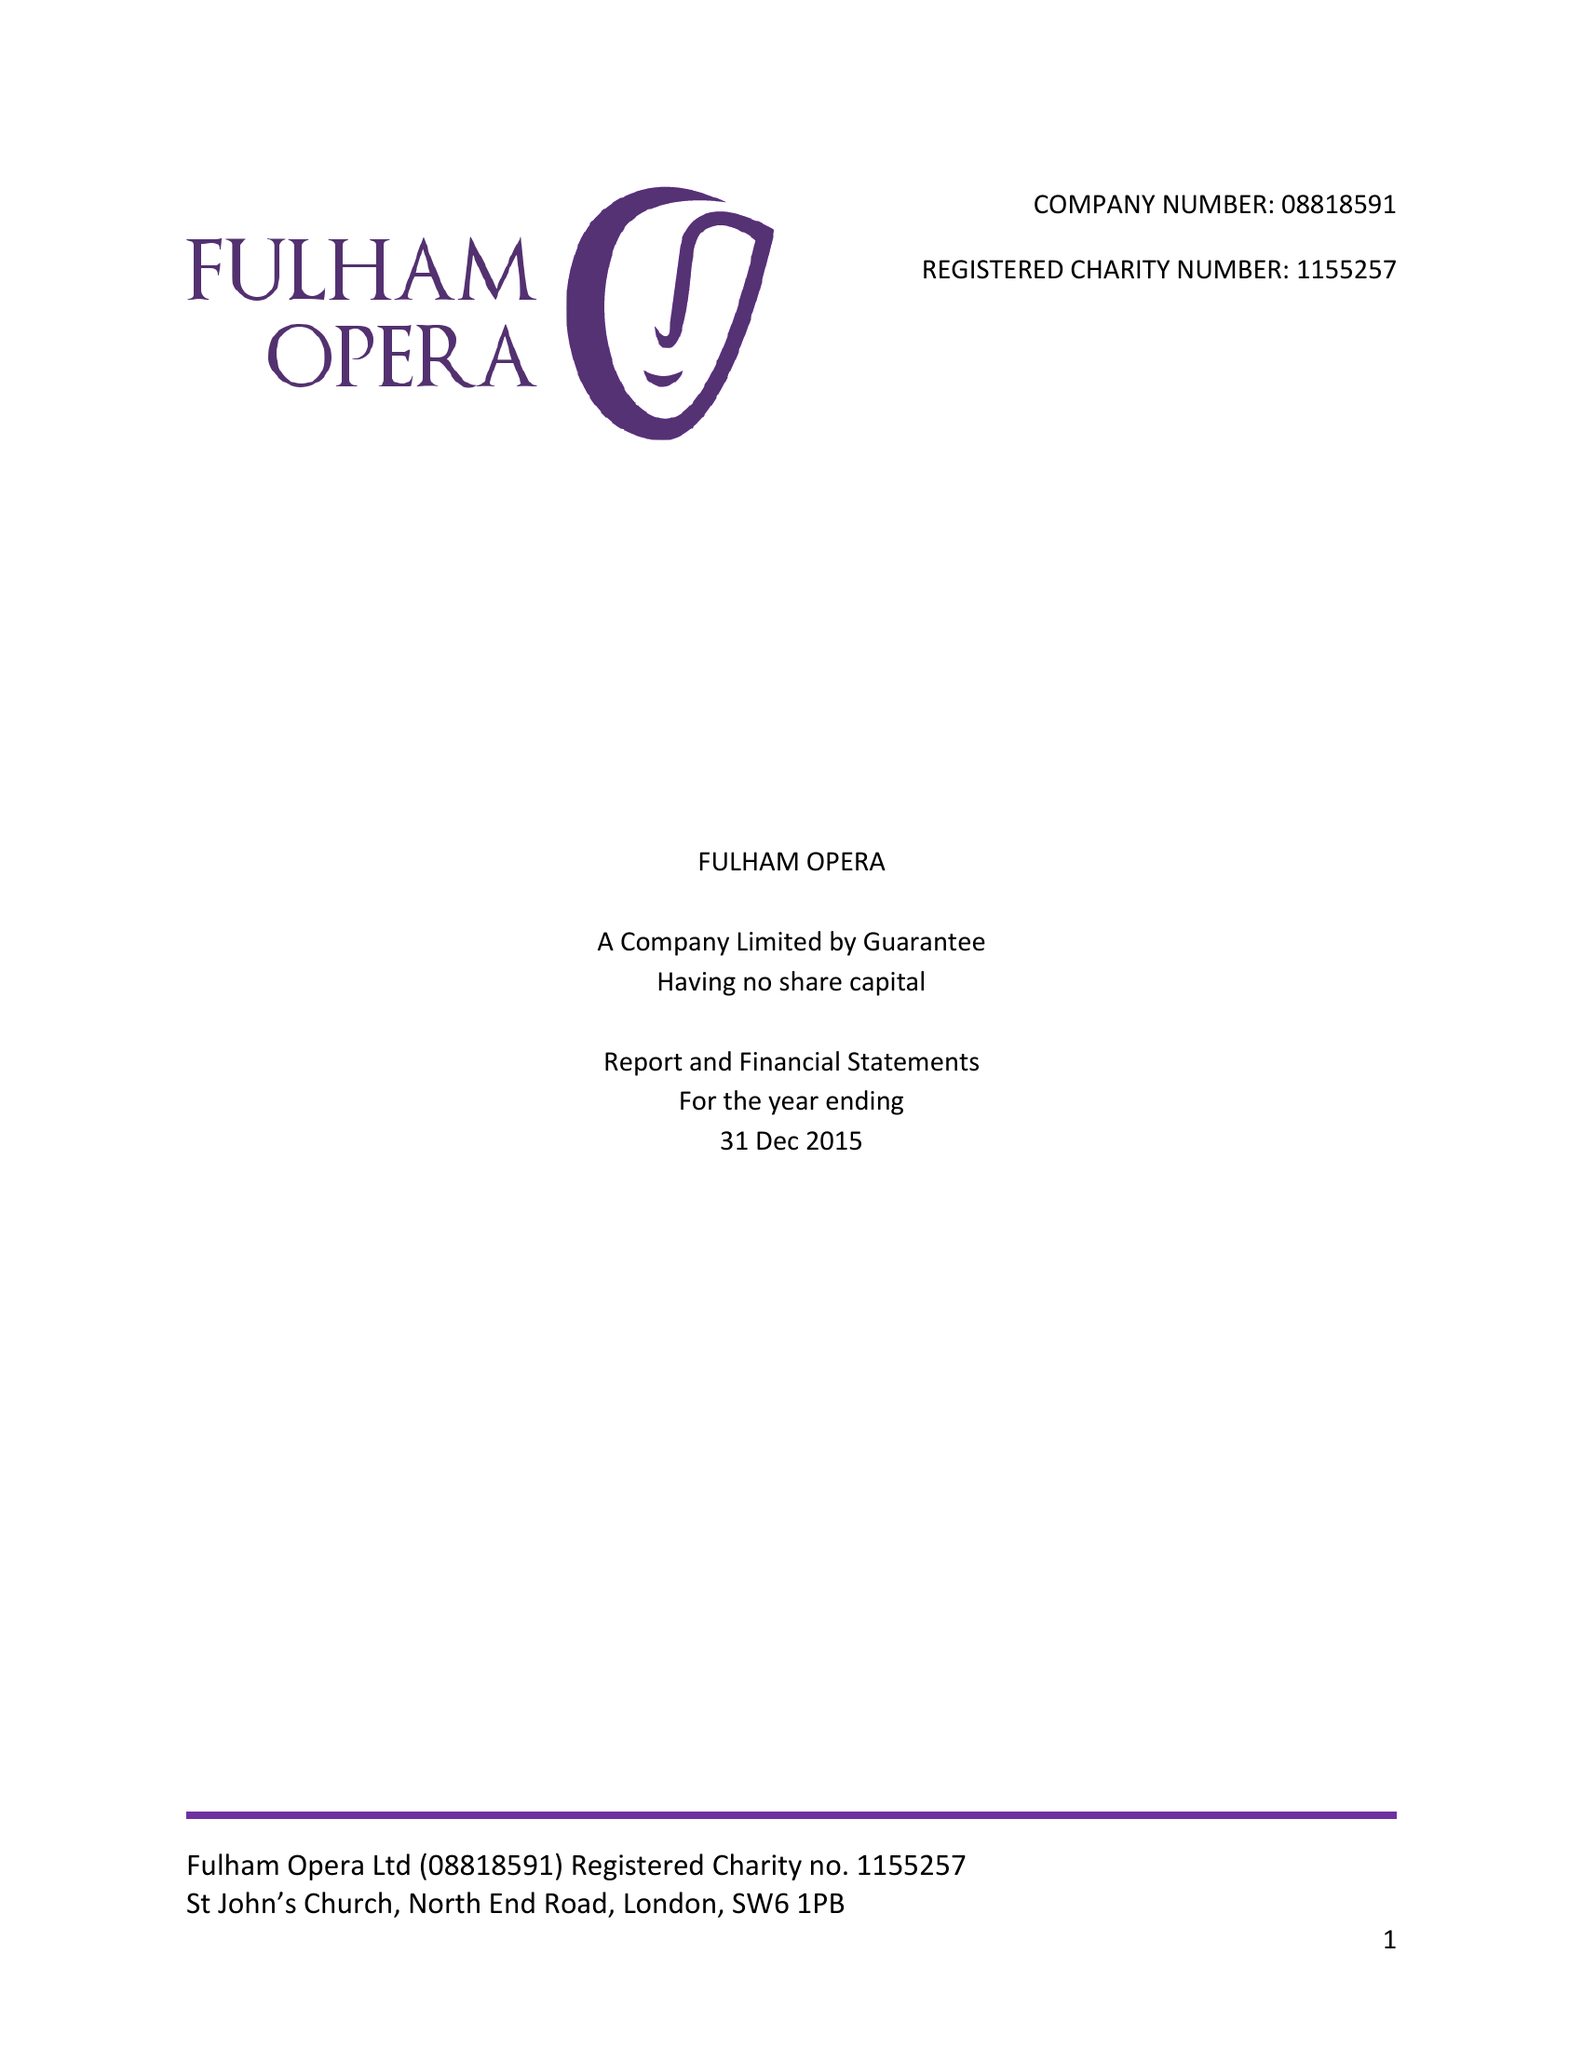What is the value for the address__postcode?
Answer the question using a single word or phrase. SW6 1PB 